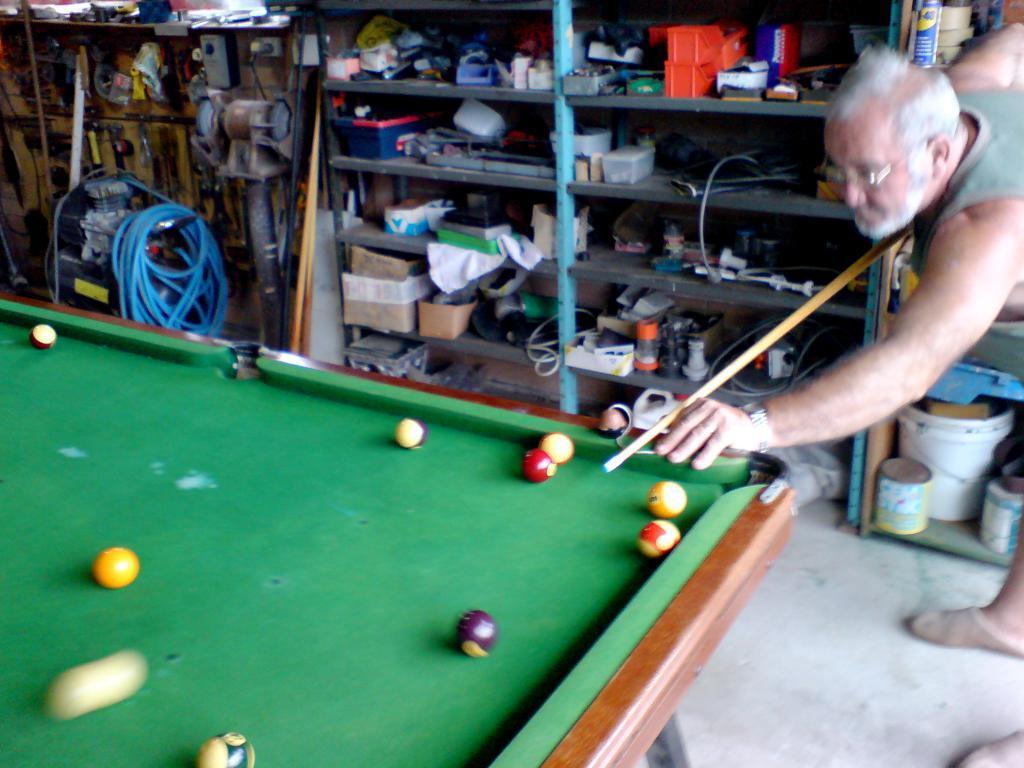In one or two sentences, can you explain what this image depicts? On the right side we can see one man holding stick. On the left side we can see table,on table we can see some balls. Coming to the background we can see the shelf on shelf we can see many tools. 